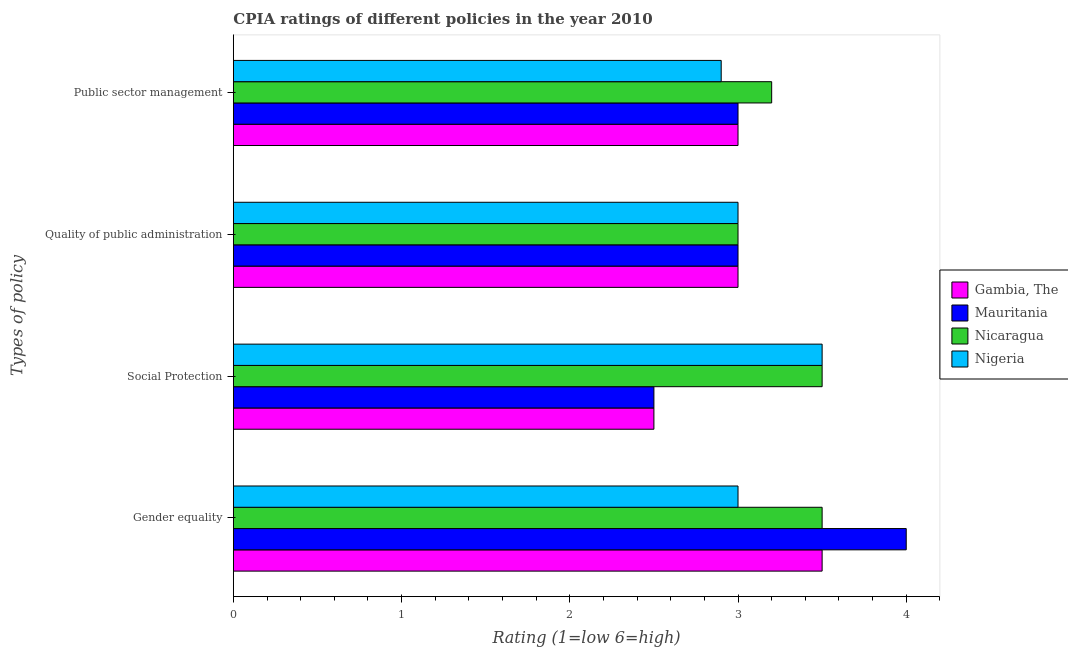How many different coloured bars are there?
Provide a short and direct response. 4. How many groups of bars are there?
Provide a succinct answer. 4. Are the number of bars per tick equal to the number of legend labels?
Ensure brevity in your answer.  Yes. How many bars are there on the 4th tick from the top?
Provide a succinct answer. 4. What is the label of the 3rd group of bars from the top?
Offer a terse response. Social Protection. Across all countries, what is the minimum cpia rating of social protection?
Offer a terse response. 2.5. In which country was the cpia rating of gender equality maximum?
Offer a very short reply. Mauritania. In which country was the cpia rating of public sector management minimum?
Ensure brevity in your answer.  Nigeria. What is the total cpia rating of public sector management in the graph?
Your answer should be compact. 12.1. What is the difference between the cpia rating of gender equality in Nigeria and that in Mauritania?
Your answer should be very brief. -1. What is the difference between the cpia rating of social protection in Gambia, The and the cpia rating of quality of public administration in Nigeria?
Make the answer very short. -0.5. What is the average cpia rating of public sector management per country?
Keep it short and to the point. 3.02. What is the ratio of the cpia rating of public sector management in Nigeria to that in Gambia, The?
Offer a very short reply. 0.97. Is the cpia rating of quality of public administration in Nigeria less than that in Gambia, The?
Ensure brevity in your answer.  No. What is the difference between the highest and the second highest cpia rating of quality of public administration?
Your response must be concise. 0. What is the difference between the highest and the lowest cpia rating of public sector management?
Your answer should be compact. 0.3. In how many countries, is the cpia rating of social protection greater than the average cpia rating of social protection taken over all countries?
Your response must be concise. 2. What does the 3rd bar from the top in Public sector management represents?
Your response must be concise. Mauritania. What does the 1st bar from the bottom in Social Protection represents?
Provide a succinct answer. Gambia, The. Is it the case that in every country, the sum of the cpia rating of gender equality and cpia rating of social protection is greater than the cpia rating of quality of public administration?
Provide a short and direct response. Yes. How many bars are there?
Provide a short and direct response. 16. Are all the bars in the graph horizontal?
Offer a very short reply. Yes. What is the difference between two consecutive major ticks on the X-axis?
Your response must be concise. 1. Does the graph contain grids?
Offer a very short reply. No. What is the title of the graph?
Keep it short and to the point. CPIA ratings of different policies in the year 2010. What is the label or title of the X-axis?
Provide a short and direct response. Rating (1=low 6=high). What is the label or title of the Y-axis?
Provide a succinct answer. Types of policy. What is the Rating (1=low 6=high) in Gambia, The in Gender equality?
Your response must be concise. 3.5. What is the Rating (1=low 6=high) of Mauritania in Gender equality?
Keep it short and to the point. 4. What is the Rating (1=low 6=high) of Nigeria in Gender equality?
Your answer should be very brief. 3. What is the Rating (1=low 6=high) in Nicaragua in Social Protection?
Provide a short and direct response. 3.5. What is the Rating (1=low 6=high) in Nigeria in Social Protection?
Offer a very short reply. 3.5. What is the Rating (1=low 6=high) in Nicaragua in Quality of public administration?
Your answer should be compact. 3. What is the Rating (1=low 6=high) in Nigeria in Quality of public administration?
Ensure brevity in your answer.  3. What is the Rating (1=low 6=high) in Gambia, The in Public sector management?
Make the answer very short. 3. What is the Rating (1=low 6=high) of Mauritania in Public sector management?
Give a very brief answer. 3. Across all Types of policy, what is the maximum Rating (1=low 6=high) in Nicaragua?
Offer a terse response. 3.5. Across all Types of policy, what is the minimum Rating (1=low 6=high) in Mauritania?
Give a very brief answer. 2.5. Across all Types of policy, what is the minimum Rating (1=low 6=high) in Nigeria?
Your answer should be very brief. 2.9. What is the difference between the Rating (1=low 6=high) in Gambia, The in Gender equality and that in Social Protection?
Provide a succinct answer. 1. What is the difference between the Rating (1=low 6=high) of Nigeria in Gender equality and that in Social Protection?
Ensure brevity in your answer.  -0.5. What is the difference between the Rating (1=low 6=high) in Gambia, The in Gender equality and that in Quality of public administration?
Ensure brevity in your answer.  0.5. What is the difference between the Rating (1=low 6=high) of Mauritania in Gender equality and that in Public sector management?
Ensure brevity in your answer.  1. What is the difference between the Rating (1=low 6=high) in Nigeria in Gender equality and that in Public sector management?
Provide a short and direct response. 0.1. What is the difference between the Rating (1=low 6=high) in Mauritania in Social Protection and that in Quality of public administration?
Make the answer very short. -0.5. What is the difference between the Rating (1=low 6=high) of Nigeria in Social Protection and that in Quality of public administration?
Give a very brief answer. 0.5. What is the difference between the Rating (1=low 6=high) in Gambia, The in Social Protection and that in Public sector management?
Provide a short and direct response. -0.5. What is the difference between the Rating (1=low 6=high) in Mauritania in Social Protection and that in Public sector management?
Make the answer very short. -0.5. What is the difference between the Rating (1=low 6=high) in Nicaragua in Social Protection and that in Public sector management?
Ensure brevity in your answer.  0.3. What is the difference between the Rating (1=low 6=high) in Nigeria in Social Protection and that in Public sector management?
Make the answer very short. 0.6. What is the difference between the Rating (1=low 6=high) of Gambia, The in Quality of public administration and that in Public sector management?
Your answer should be very brief. 0. What is the difference between the Rating (1=low 6=high) of Mauritania in Quality of public administration and that in Public sector management?
Your response must be concise. 0. What is the difference between the Rating (1=low 6=high) in Nicaragua in Quality of public administration and that in Public sector management?
Ensure brevity in your answer.  -0.2. What is the difference between the Rating (1=low 6=high) in Gambia, The in Gender equality and the Rating (1=low 6=high) in Nigeria in Social Protection?
Ensure brevity in your answer.  0. What is the difference between the Rating (1=low 6=high) of Mauritania in Gender equality and the Rating (1=low 6=high) of Nigeria in Social Protection?
Offer a terse response. 0.5. What is the difference between the Rating (1=low 6=high) of Nicaragua in Gender equality and the Rating (1=low 6=high) of Nigeria in Social Protection?
Give a very brief answer. 0. What is the difference between the Rating (1=low 6=high) of Gambia, The in Gender equality and the Rating (1=low 6=high) of Nicaragua in Quality of public administration?
Give a very brief answer. 0.5. What is the difference between the Rating (1=low 6=high) in Mauritania in Gender equality and the Rating (1=low 6=high) in Nicaragua in Quality of public administration?
Your answer should be very brief. 1. What is the difference between the Rating (1=low 6=high) of Mauritania in Gender equality and the Rating (1=low 6=high) of Nigeria in Quality of public administration?
Provide a succinct answer. 1. What is the difference between the Rating (1=low 6=high) in Nicaragua in Gender equality and the Rating (1=low 6=high) in Nigeria in Quality of public administration?
Your answer should be compact. 0.5. What is the difference between the Rating (1=low 6=high) of Gambia, The in Gender equality and the Rating (1=low 6=high) of Nigeria in Public sector management?
Provide a short and direct response. 0.6. What is the difference between the Rating (1=low 6=high) of Mauritania in Gender equality and the Rating (1=low 6=high) of Nigeria in Public sector management?
Provide a short and direct response. 1.1. What is the difference between the Rating (1=low 6=high) of Gambia, The in Social Protection and the Rating (1=low 6=high) of Mauritania in Quality of public administration?
Make the answer very short. -0.5. What is the difference between the Rating (1=low 6=high) of Gambia, The in Social Protection and the Rating (1=low 6=high) of Nicaragua in Quality of public administration?
Offer a terse response. -0.5. What is the difference between the Rating (1=low 6=high) in Gambia, The in Social Protection and the Rating (1=low 6=high) in Nigeria in Quality of public administration?
Your answer should be very brief. -0.5. What is the difference between the Rating (1=low 6=high) of Mauritania in Social Protection and the Rating (1=low 6=high) of Nicaragua in Quality of public administration?
Keep it short and to the point. -0.5. What is the difference between the Rating (1=low 6=high) of Nicaragua in Social Protection and the Rating (1=low 6=high) of Nigeria in Quality of public administration?
Provide a succinct answer. 0.5. What is the difference between the Rating (1=low 6=high) of Gambia, The in Social Protection and the Rating (1=low 6=high) of Nicaragua in Public sector management?
Offer a terse response. -0.7. What is the difference between the Rating (1=low 6=high) in Gambia, The in Quality of public administration and the Rating (1=low 6=high) in Mauritania in Public sector management?
Offer a terse response. 0. What is the difference between the Rating (1=low 6=high) of Nicaragua in Quality of public administration and the Rating (1=low 6=high) of Nigeria in Public sector management?
Provide a short and direct response. 0.1. What is the average Rating (1=low 6=high) in Mauritania per Types of policy?
Ensure brevity in your answer.  3.12. What is the average Rating (1=low 6=high) in Nicaragua per Types of policy?
Your response must be concise. 3.3. What is the average Rating (1=low 6=high) in Nigeria per Types of policy?
Provide a short and direct response. 3.1. What is the difference between the Rating (1=low 6=high) in Gambia, The and Rating (1=low 6=high) in Mauritania in Gender equality?
Your answer should be very brief. -0.5. What is the difference between the Rating (1=low 6=high) of Gambia, The and Rating (1=low 6=high) of Nigeria in Gender equality?
Your answer should be very brief. 0.5. What is the difference between the Rating (1=low 6=high) of Mauritania and Rating (1=low 6=high) of Nigeria in Gender equality?
Your answer should be compact. 1. What is the difference between the Rating (1=low 6=high) of Gambia, The and Rating (1=low 6=high) of Mauritania in Social Protection?
Give a very brief answer. 0. What is the difference between the Rating (1=low 6=high) in Gambia, The and Rating (1=low 6=high) in Nigeria in Social Protection?
Provide a succinct answer. -1. What is the difference between the Rating (1=low 6=high) in Gambia, The and Rating (1=low 6=high) in Nigeria in Quality of public administration?
Offer a very short reply. 0. What is the difference between the Rating (1=low 6=high) in Mauritania and Rating (1=low 6=high) in Nigeria in Quality of public administration?
Offer a terse response. 0. What is the difference between the Rating (1=low 6=high) of Nicaragua and Rating (1=low 6=high) of Nigeria in Quality of public administration?
Your answer should be compact. 0. What is the difference between the Rating (1=low 6=high) in Gambia, The and Rating (1=low 6=high) in Mauritania in Public sector management?
Provide a short and direct response. 0. What is the ratio of the Rating (1=low 6=high) of Gambia, The in Gender equality to that in Social Protection?
Keep it short and to the point. 1.4. What is the ratio of the Rating (1=low 6=high) of Nicaragua in Gender equality to that in Social Protection?
Provide a succinct answer. 1. What is the ratio of the Rating (1=low 6=high) of Nigeria in Gender equality to that in Social Protection?
Offer a terse response. 0.86. What is the ratio of the Rating (1=low 6=high) in Nicaragua in Gender equality to that in Quality of public administration?
Ensure brevity in your answer.  1.17. What is the ratio of the Rating (1=low 6=high) in Gambia, The in Gender equality to that in Public sector management?
Provide a short and direct response. 1.17. What is the ratio of the Rating (1=low 6=high) of Nicaragua in Gender equality to that in Public sector management?
Offer a very short reply. 1.09. What is the ratio of the Rating (1=low 6=high) of Nigeria in Gender equality to that in Public sector management?
Ensure brevity in your answer.  1.03. What is the ratio of the Rating (1=low 6=high) in Nicaragua in Social Protection to that in Quality of public administration?
Your response must be concise. 1.17. What is the ratio of the Rating (1=low 6=high) in Nicaragua in Social Protection to that in Public sector management?
Keep it short and to the point. 1.09. What is the ratio of the Rating (1=low 6=high) in Nigeria in Social Protection to that in Public sector management?
Your answer should be compact. 1.21. What is the ratio of the Rating (1=low 6=high) in Gambia, The in Quality of public administration to that in Public sector management?
Your answer should be compact. 1. What is the ratio of the Rating (1=low 6=high) in Nicaragua in Quality of public administration to that in Public sector management?
Provide a succinct answer. 0.94. What is the ratio of the Rating (1=low 6=high) of Nigeria in Quality of public administration to that in Public sector management?
Provide a short and direct response. 1.03. What is the difference between the highest and the second highest Rating (1=low 6=high) of Mauritania?
Offer a very short reply. 1. What is the difference between the highest and the second highest Rating (1=low 6=high) in Nicaragua?
Your answer should be compact. 0. What is the difference between the highest and the second highest Rating (1=low 6=high) of Nigeria?
Your answer should be compact. 0.5. What is the difference between the highest and the lowest Rating (1=low 6=high) in Mauritania?
Your answer should be compact. 1.5. 